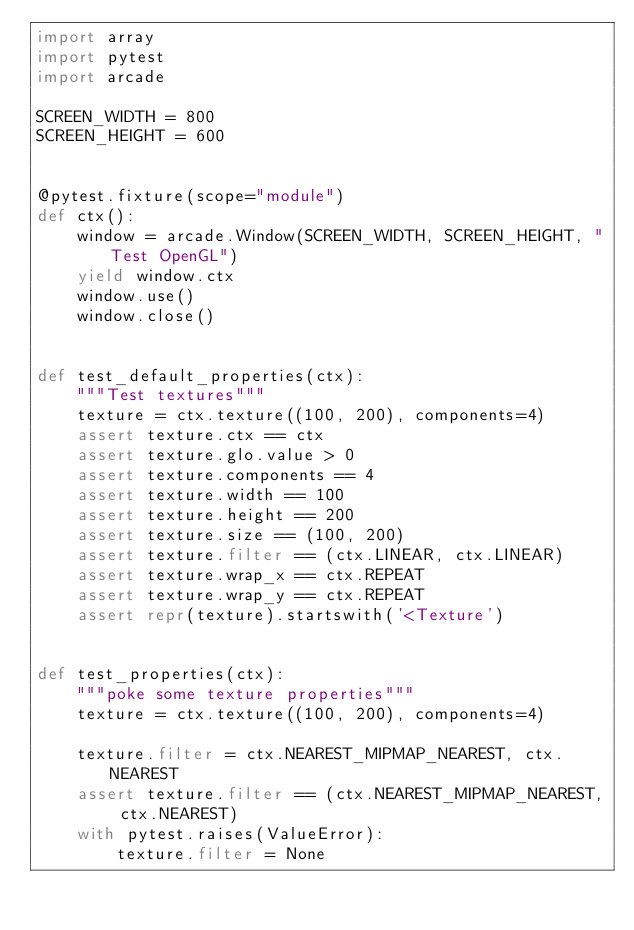Convert code to text. <code><loc_0><loc_0><loc_500><loc_500><_Python_>import array
import pytest
import arcade

SCREEN_WIDTH = 800
SCREEN_HEIGHT = 600


@pytest.fixture(scope="module")
def ctx():
    window = arcade.Window(SCREEN_WIDTH, SCREEN_HEIGHT, "Test OpenGL")
    yield window.ctx
    window.use()
    window.close()


def test_default_properties(ctx):
    """Test textures"""
    texture = ctx.texture((100, 200), components=4)
    assert texture.ctx == ctx
    assert texture.glo.value > 0
    assert texture.components == 4
    assert texture.width == 100
    assert texture.height == 200
    assert texture.size == (100, 200)
    assert texture.filter == (ctx.LINEAR, ctx.LINEAR)
    assert texture.wrap_x == ctx.REPEAT
    assert texture.wrap_y == ctx.REPEAT
    assert repr(texture).startswith('<Texture')


def test_properties(ctx):
    """poke some texture properties"""
    texture = ctx.texture((100, 200), components=4)

    texture.filter = ctx.NEAREST_MIPMAP_NEAREST, ctx.NEAREST
    assert texture.filter == (ctx.NEAREST_MIPMAP_NEAREST, ctx.NEAREST)
    with pytest.raises(ValueError):
        texture.filter = None
</code> 